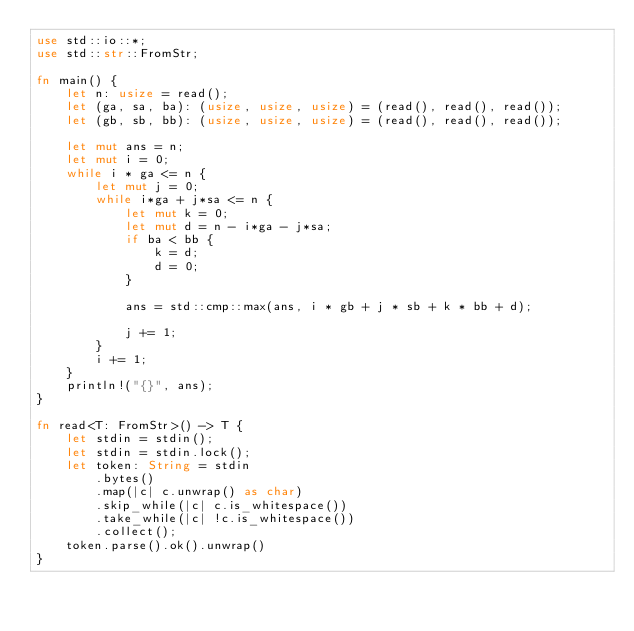Convert code to text. <code><loc_0><loc_0><loc_500><loc_500><_Rust_>use std::io::*;
use std::str::FromStr;

fn main() {
    let n: usize = read();
    let (ga, sa, ba): (usize, usize, usize) = (read(), read(), read());
    let (gb, sb, bb): (usize, usize, usize) = (read(), read(), read());

    let mut ans = n;
    let mut i = 0;
    while i * ga <= n {
        let mut j = 0;
        while i*ga + j*sa <= n {
            let mut k = 0;
            let mut d = n - i*ga - j*sa;
            if ba < bb {
                k = d;
                d = 0;
            }

            ans = std::cmp::max(ans, i * gb + j * sb + k * bb + d);

            j += 1;
        }
        i += 1;
    }
    println!("{}", ans);
}

fn read<T: FromStr>() -> T {
    let stdin = stdin();
    let stdin = stdin.lock();
    let token: String = stdin
        .bytes()
        .map(|c| c.unwrap() as char)
        .skip_while(|c| c.is_whitespace())
        .take_while(|c| !c.is_whitespace())
        .collect();
    token.parse().ok().unwrap()
}
</code> 